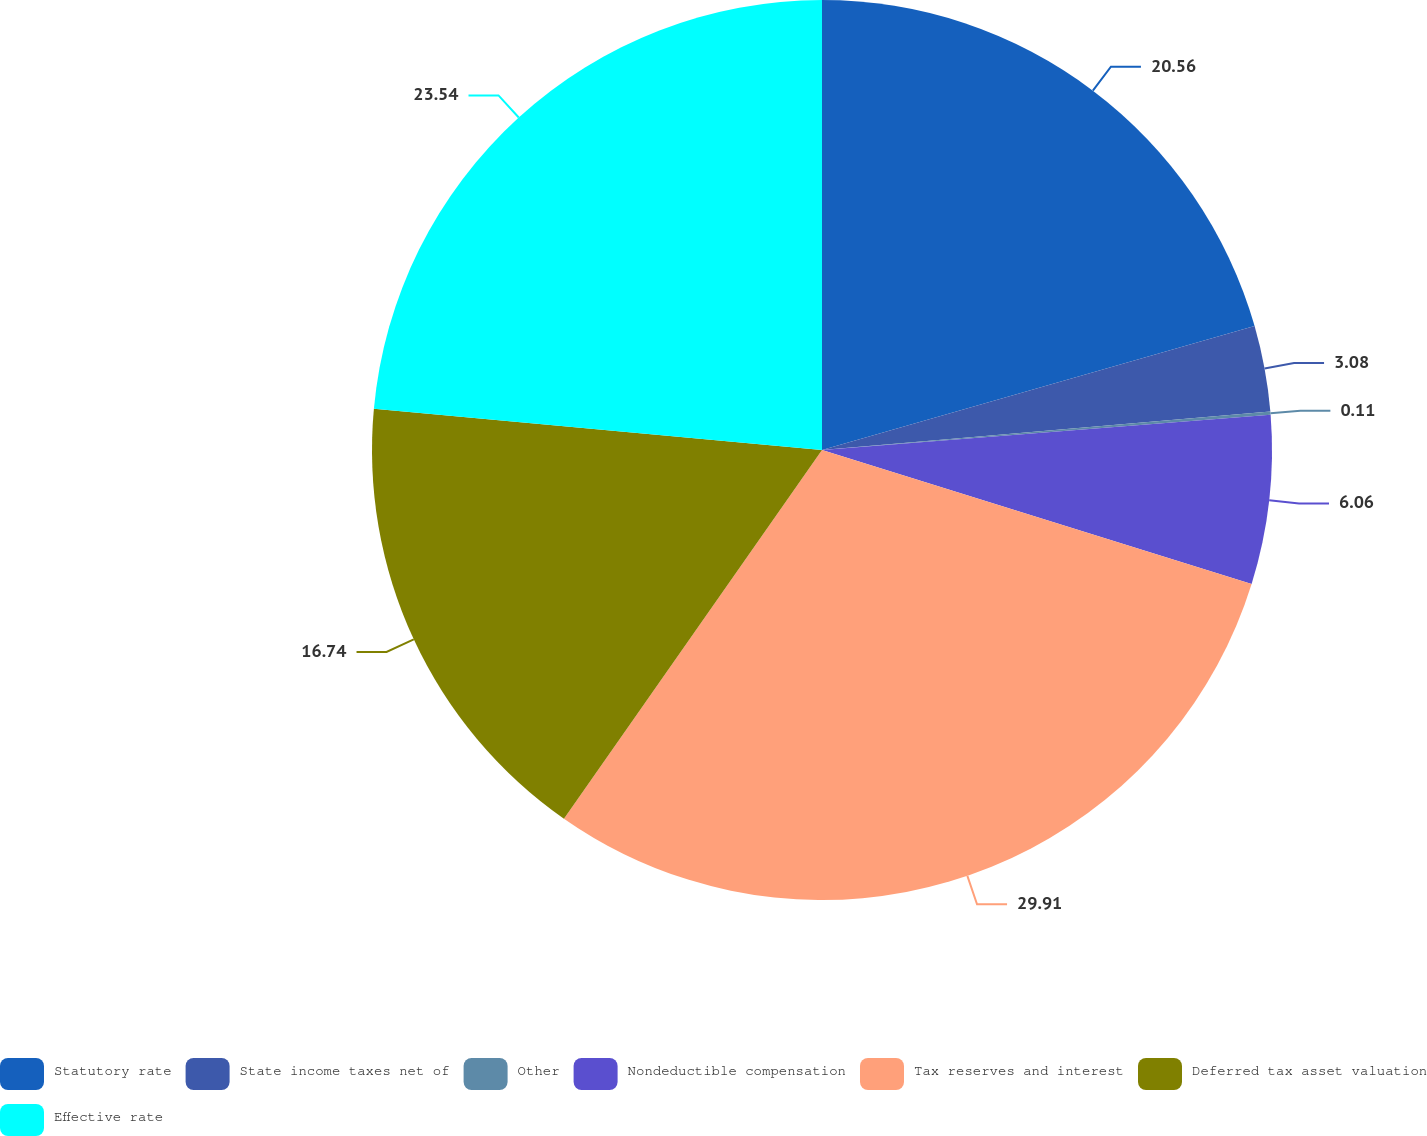<chart> <loc_0><loc_0><loc_500><loc_500><pie_chart><fcel>Statutory rate<fcel>State income taxes net of<fcel>Other<fcel>Nondeductible compensation<fcel>Tax reserves and interest<fcel>Deferred tax asset valuation<fcel>Effective rate<nl><fcel>20.56%<fcel>3.08%<fcel>0.11%<fcel>6.06%<fcel>29.91%<fcel>16.74%<fcel>23.54%<nl></chart> 